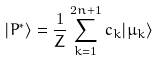Convert formula to latex. <formula><loc_0><loc_0><loc_500><loc_500>| P ^ { \ast } \rangle = \frac { 1 } { Z } \sum _ { k = 1 } ^ { 2 n + 1 } c _ { k } | \mu _ { k } \rangle</formula> 